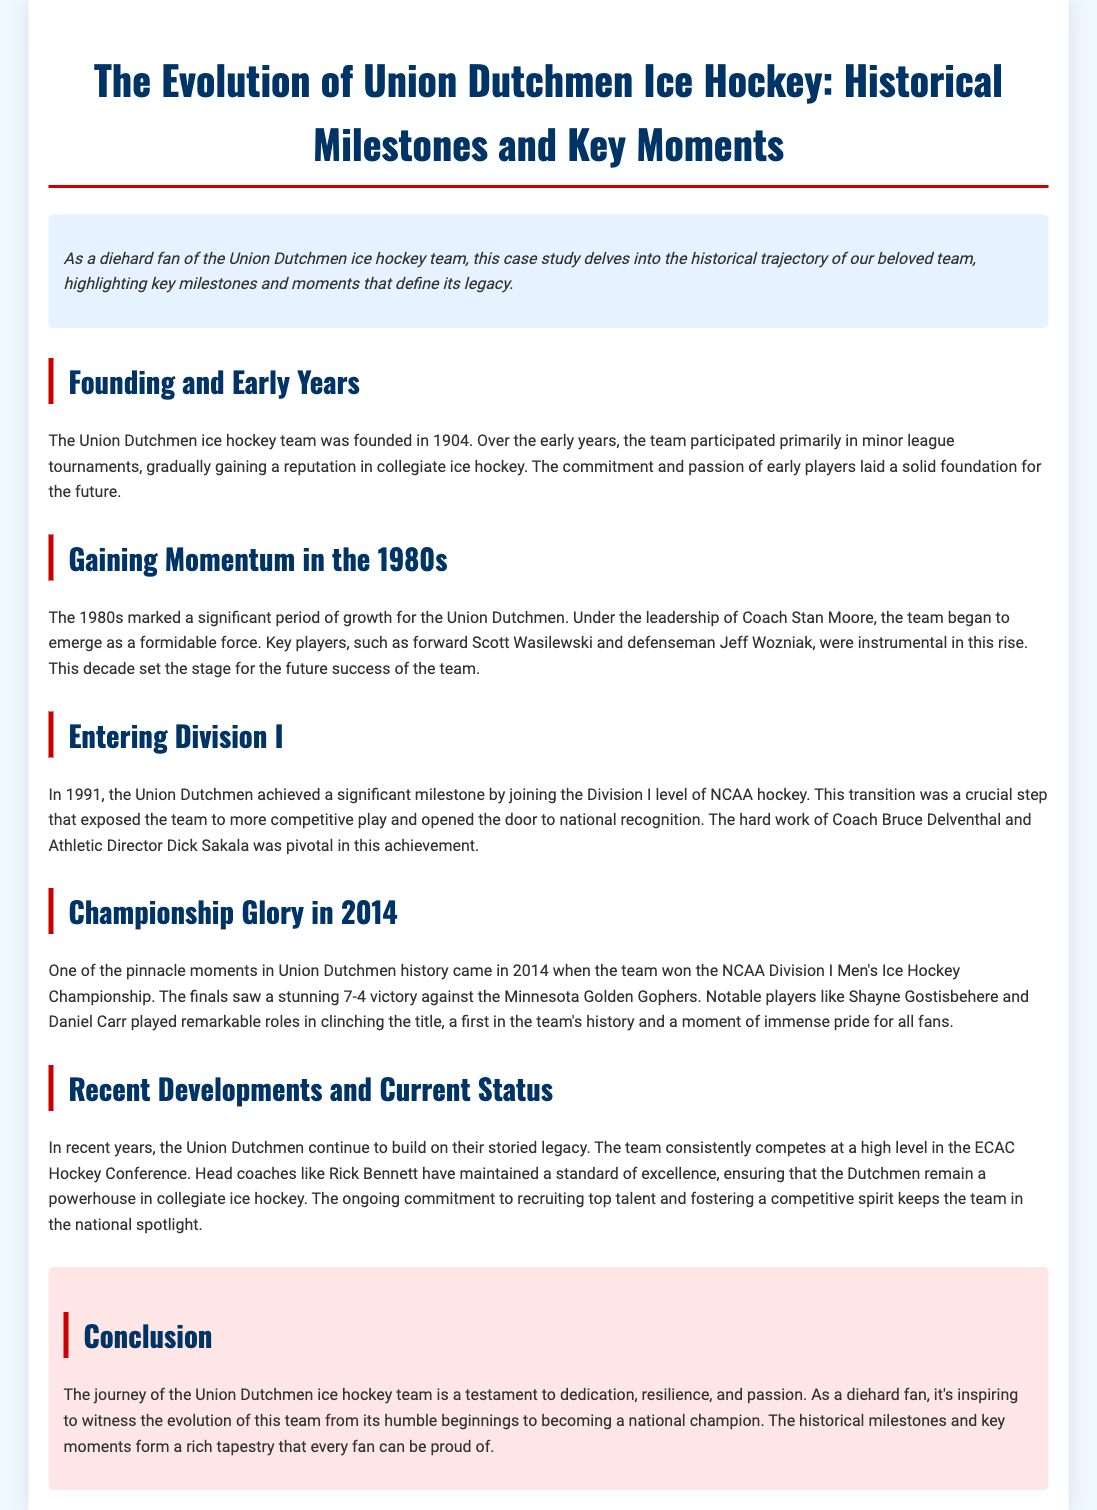What year was the Union Dutchmen ice hockey team founded? The founding year of the Union Dutchmen ice hockey team is explicitly mentioned in the document.
Answer: 1904 Who coached the Union Dutchmen during the 1980s? The document states that Coach Stan Moore led the team during this significant period.
Answer: Stan Moore What milestone did the Union Dutchmen achieve in 1991? The document highlights a pivotal moment in 1991 where the team reached a significant level in NCAA hockey.
Answer: Joining Division I What championship did the Union Dutchmen win in 2014? The document references a specific NCAA championship won by the team, providing details about the event.
Answer: NCAA Division I Men's Ice Hockey Championship Who were two notable players in the 2014 championship victory? The document lists key individuals who played significant roles during the championship match.
Answer: Shayne Gostisbehere and Daniel Carr What is the current conference the Union Dutchmen compete in? The document provides information about the team's current competitive setting.
Answer: ECAC Hockey Conference What has been a consistent factor in the team's recent success? The document mentions the importance of recruiting top talent and maintaining a competitive spirit for the team's performance.
Answer: Recruiting top talent In what year did the Union Dutchmen achieve national recognition? The document states the year the team transitioned to a more competitive level leading to national recognition.
Answer: 1991 